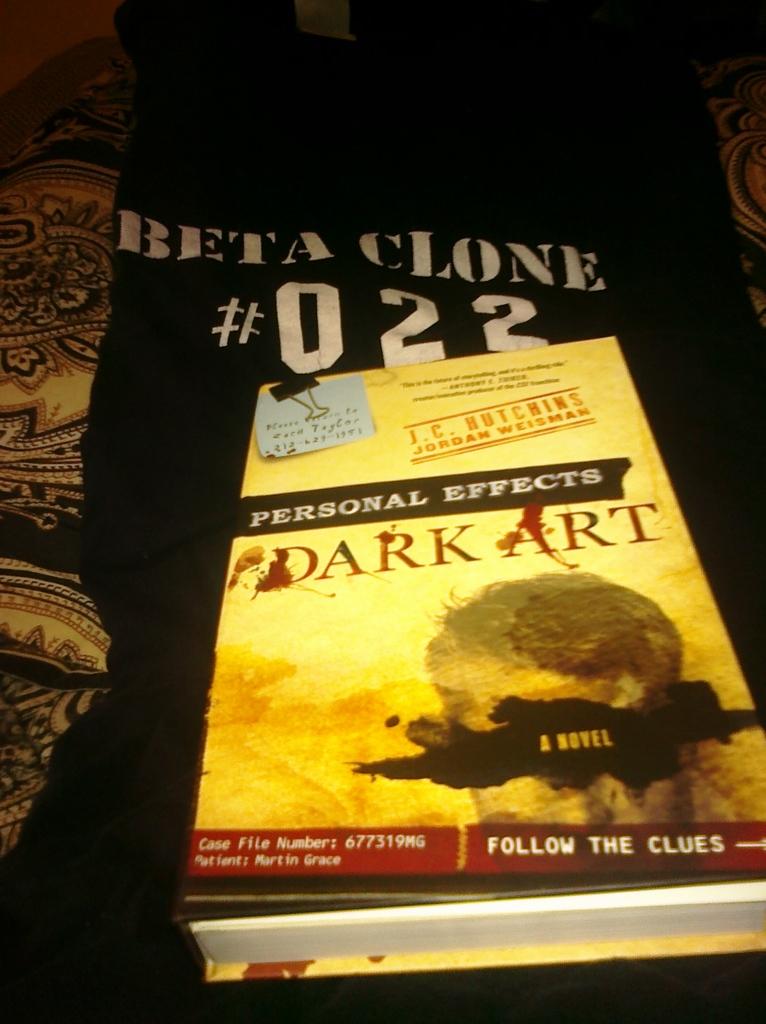What is the case file number?
Your answer should be very brief. 677319mg. 